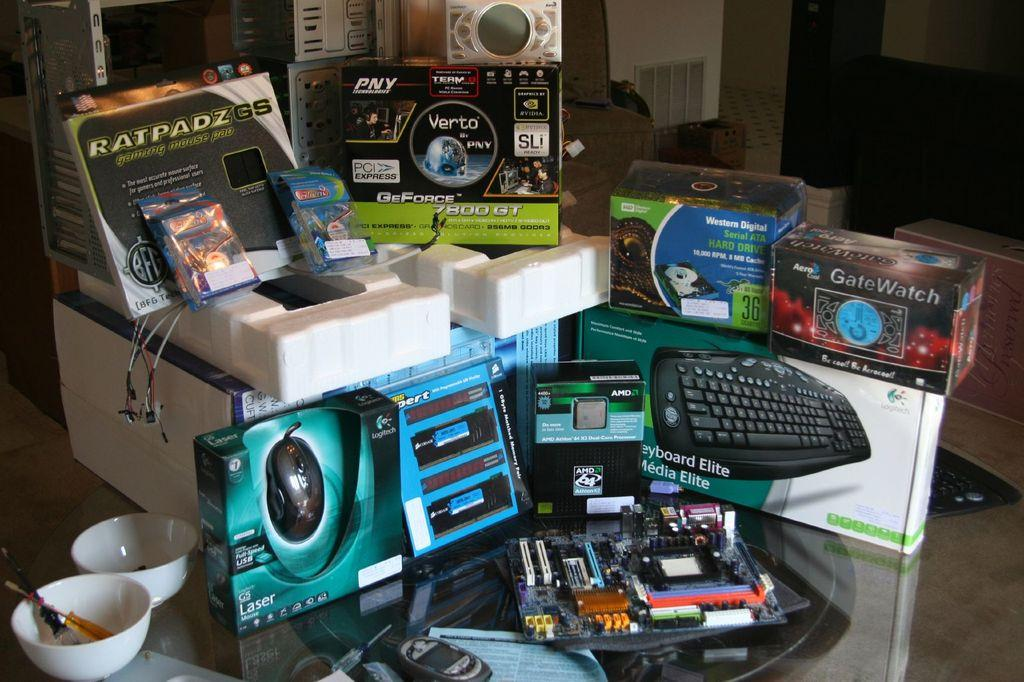What type of objects can be seen in the image? There are boxes, cabins, and a motherboard in the image. Where are the bowls located in the image? The bowls are in the bottom left of the image. What type of bomb can be seen in the image? There is no bomb present in the image. What type of gate is visible in the image? There is no gate present in the image. 